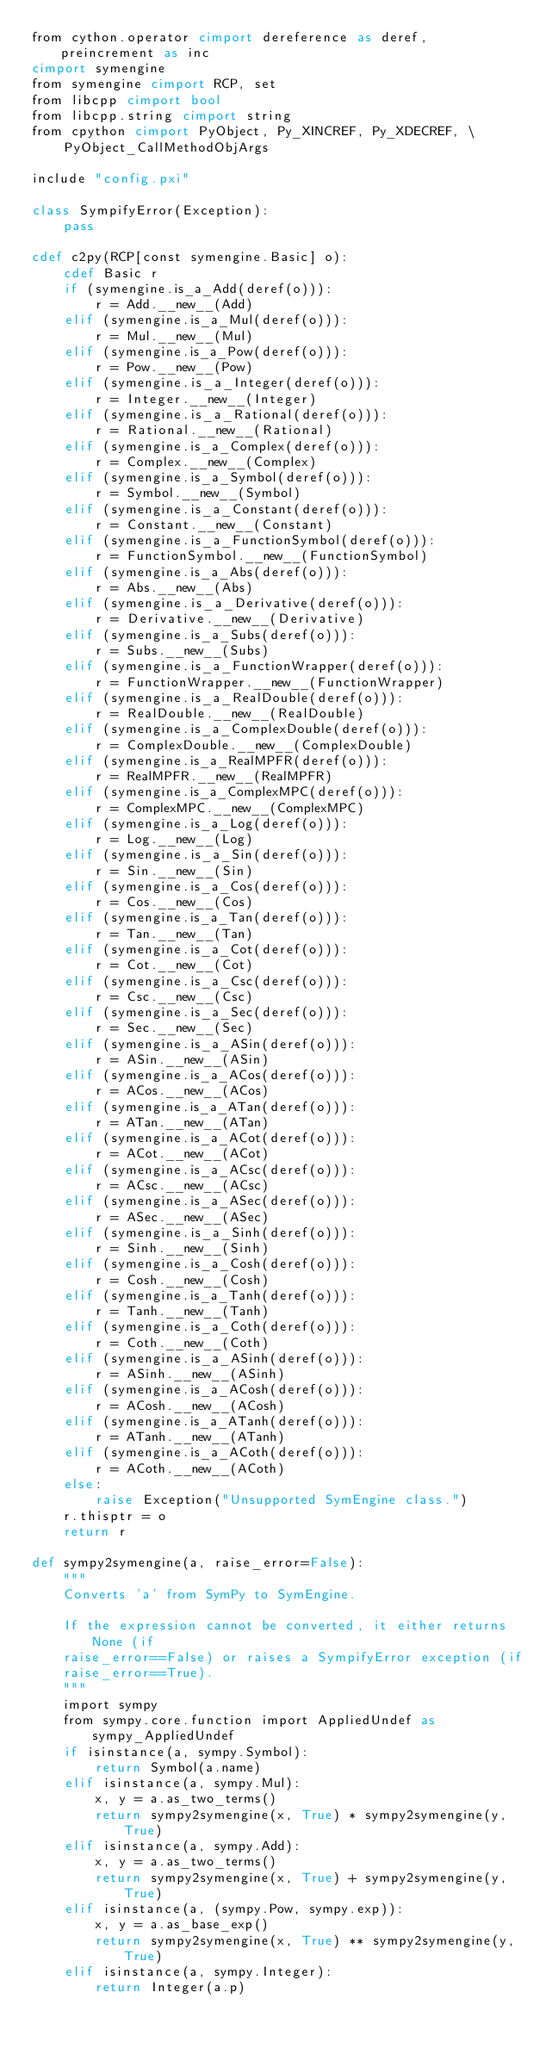Convert code to text. <code><loc_0><loc_0><loc_500><loc_500><_Cython_>from cython.operator cimport dereference as deref, preincrement as inc
cimport symengine
from symengine cimport RCP, set
from libcpp cimport bool
from libcpp.string cimport string
from cpython cimport PyObject, Py_XINCREF, Py_XDECREF, \
    PyObject_CallMethodObjArgs

include "config.pxi"

class SympifyError(Exception):
    pass

cdef c2py(RCP[const symengine.Basic] o):
    cdef Basic r
    if (symengine.is_a_Add(deref(o))):
        r = Add.__new__(Add)
    elif (symengine.is_a_Mul(deref(o))):
        r = Mul.__new__(Mul)
    elif (symengine.is_a_Pow(deref(o))):
        r = Pow.__new__(Pow)
    elif (symengine.is_a_Integer(deref(o))):
        r = Integer.__new__(Integer)
    elif (symengine.is_a_Rational(deref(o))):
        r = Rational.__new__(Rational)
    elif (symengine.is_a_Complex(deref(o))):
        r = Complex.__new__(Complex)
    elif (symengine.is_a_Symbol(deref(o))):
        r = Symbol.__new__(Symbol)
    elif (symengine.is_a_Constant(deref(o))):
        r = Constant.__new__(Constant)
    elif (symengine.is_a_FunctionSymbol(deref(o))):
        r = FunctionSymbol.__new__(FunctionSymbol)
    elif (symengine.is_a_Abs(deref(o))):
        r = Abs.__new__(Abs)
    elif (symengine.is_a_Derivative(deref(o))):
        r = Derivative.__new__(Derivative)
    elif (symengine.is_a_Subs(deref(o))):
        r = Subs.__new__(Subs)
    elif (symengine.is_a_FunctionWrapper(deref(o))):
        r = FunctionWrapper.__new__(FunctionWrapper)
    elif (symengine.is_a_RealDouble(deref(o))):
        r = RealDouble.__new__(RealDouble)
    elif (symengine.is_a_ComplexDouble(deref(o))):
        r = ComplexDouble.__new__(ComplexDouble)
    elif (symengine.is_a_RealMPFR(deref(o))):
        r = RealMPFR.__new__(RealMPFR)
    elif (symengine.is_a_ComplexMPC(deref(o))):
        r = ComplexMPC.__new__(ComplexMPC)
    elif (symengine.is_a_Log(deref(o))):
        r = Log.__new__(Log)
    elif (symengine.is_a_Sin(deref(o))):
        r = Sin.__new__(Sin)
    elif (symengine.is_a_Cos(deref(o))):
        r = Cos.__new__(Cos)
    elif (symengine.is_a_Tan(deref(o))):
        r = Tan.__new__(Tan)
    elif (symengine.is_a_Cot(deref(o))):
        r = Cot.__new__(Cot)
    elif (symengine.is_a_Csc(deref(o))):
        r = Csc.__new__(Csc)
    elif (symengine.is_a_Sec(deref(o))):
        r = Sec.__new__(Sec)
    elif (symengine.is_a_ASin(deref(o))):
        r = ASin.__new__(ASin)
    elif (symengine.is_a_ACos(deref(o))):
        r = ACos.__new__(ACos)
    elif (symengine.is_a_ATan(deref(o))):
        r = ATan.__new__(ATan)
    elif (symengine.is_a_ACot(deref(o))):
        r = ACot.__new__(ACot)
    elif (symengine.is_a_ACsc(deref(o))):
        r = ACsc.__new__(ACsc)
    elif (symengine.is_a_ASec(deref(o))):
        r = ASec.__new__(ASec)
    elif (symengine.is_a_Sinh(deref(o))):
        r = Sinh.__new__(Sinh)
    elif (symengine.is_a_Cosh(deref(o))):
        r = Cosh.__new__(Cosh)
    elif (symengine.is_a_Tanh(deref(o))):
        r = Tanh.__new__(Tanh)
    elif (symengine.is_a_Coth(deref(o))):
        r = Coth.__new__(Coth)
    elif (symengine.is_a_ASinh(deref(o))):
        r = ASinh.__new__(ASinh)
    elif (symengine.is_a_ACosh(deref(o))):
        r = ACosh.__new__(ACosh)
    elif (symengine.is_a_ATanh(deref(o))):
        r = ATanh.__new__(ATanh)
    elif (symengine.is_a_ACoth(deref(o))):
        r = ACoth.__new__(ACoth)
    else:
        raise Exception("Unsupported SymEngine class.")
    r.thisptr = o
    return r

def sympy2symengine(a, raise_error=False):
    """
    Converts 'a' from SymPy to SymEngine.

    If the expression cannot be converted, it either returns None (if
    raise_error==False) or raises a SympifyError exception (if
    raise_error==True).
    """
    import sympy
    from sympy.core.function import AppliedUndef as sympy_AppliedUndef
    if isinstance(a, sympy.Symbol):
        return Symbol(a.name)
    elif isinstance(a, sympy.Mul):
        x, y = a.as_two_terms()
        return sympy2symengine(x, True) * sympy2symengine(y, True)
    elif isinstance(a, sympy.Add):
        x, y = a.as_two_terms()
        return sympy2symengine(x, True) + sympy2symengine(y, True)
    elif isinstance(a, (sympy.Pow, sympy.exp)):
        x, y = a.as_base_exp()
        return sympy2symengine(x, True) ** sympy2symengine(y, True)
    elif isinstance(a, sympy.Integer):
        return Integer(a.p)</code> 